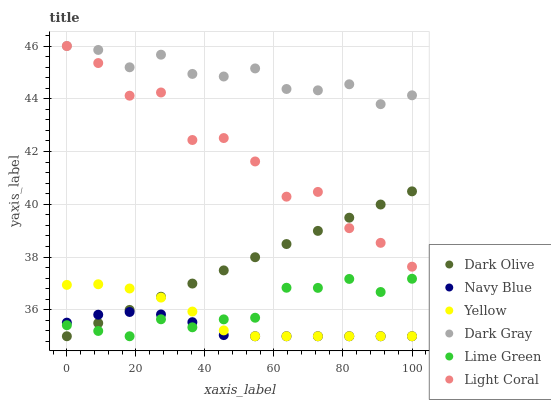Does Navy Blue have the minimum area under the curve?
Answer yes or no. Yes. Does Dark Gray have the maximum area under the curve?
Answer yes or no. Yes. Does Dark Olive have the minimum area under the curve?
Answer yes or no. No. Does Dark Olive have the maximum area under the curve?
Answer yes or no. No. Is Dark Olive the smoothest?
Answer yes or no. Yes. Is Light Coral the roughest?
Answer yes or no. Yes. Is Navy Blue the smoothest?
Answer yes or no. No. Is Navy Blue the roughest?
Answer yes or no. No. Does Navy Blue have the lowest value?
Answer yes or no. Yes. Does Dark Gray have the lowest value?
Answer yes or no. No. Does Dark Gray have the highest value?
Answer yes or no. Yes. Does Dark Olive have the highest value?
Answer yes or no. No. Is Lime Green less than Light Coral?
Answer yes or no. Yes. Is Dark Gray greater than Dark Olive?
Answer yes or no. Yes. Does Navy Blue intersect Dark Olive?
Answer yes or no. Yes. Is Navy Blue less than Dark Olive?
Answer yes or no. No. Is Navy Blue greater than Dark Olive?
Answer yes or no. No. Does Lime Green intersect Light Coral?
Answer yes or no. No. 